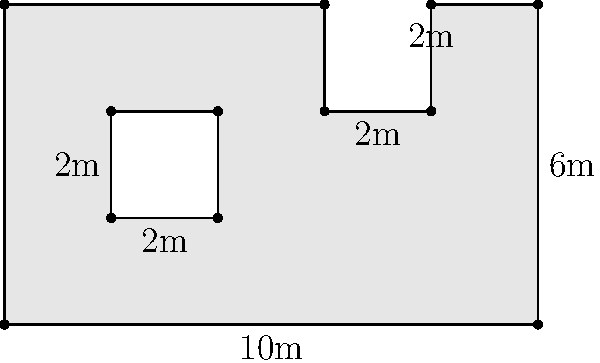As the union leader, you need to calculate the total usable floor area of the factory to ensure proper space allocation during the layoff process. The factory floor plan is shown above, with all measurements in meters. The plan includes a rectangular cutout in the center (representing a non-usable area). What is the total usable floor area of the factory in square meters? To calculate the total usable floor area, we need to follow these steps:

1. Calculate the area of the entire rectangular factory:
   $A_{total} = 10m \times 6m = 60m^2$

2. Calculate the area of the L-shaped cutout on the right:
   $A_{cutout1} = 2m \times 2m = 4m^2$

3. Calculate the area of the rectangular cutout in the center:
   $A_{cutout2} = 2m \times 2m = 4m^2$

4. Subtract the areas of both cutouts from the total area:
   $A_{usable} = A_{total} - A_{cutout1} - A_{cutout2}$
   $A_{usable} = 60m^2 - 4m^2 - 4m^2 = 52m^2$

Therefore, the total usable floor area of the factory is 52 square meters.
Answer: 52 m² 